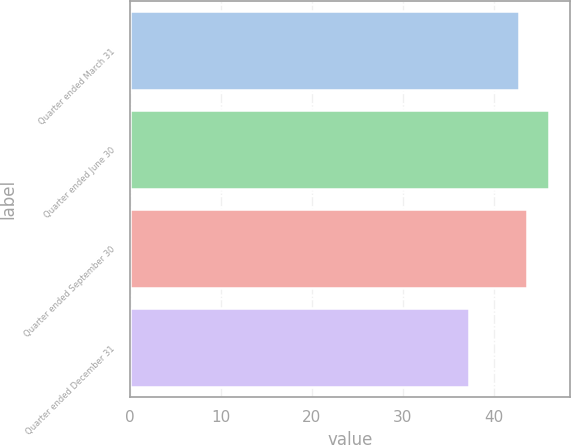Convert chart to OTSL. <chart><loc_0><loc_0><loc_500><loc_500><bar_chart><fcel>Quarter ended March 31<fcel>Quarter ended June 30<fcel>Quarter ended September 30<fcel>Quarter ended December 31<nl><fcel>42.72<fcel>46.1<fcel>43.6<fcel>37.28<nl></chart> 